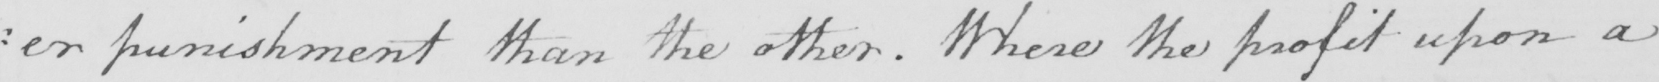Can you read and transcribe this handwriting? :er punishment than the other. Where the profit upon a 